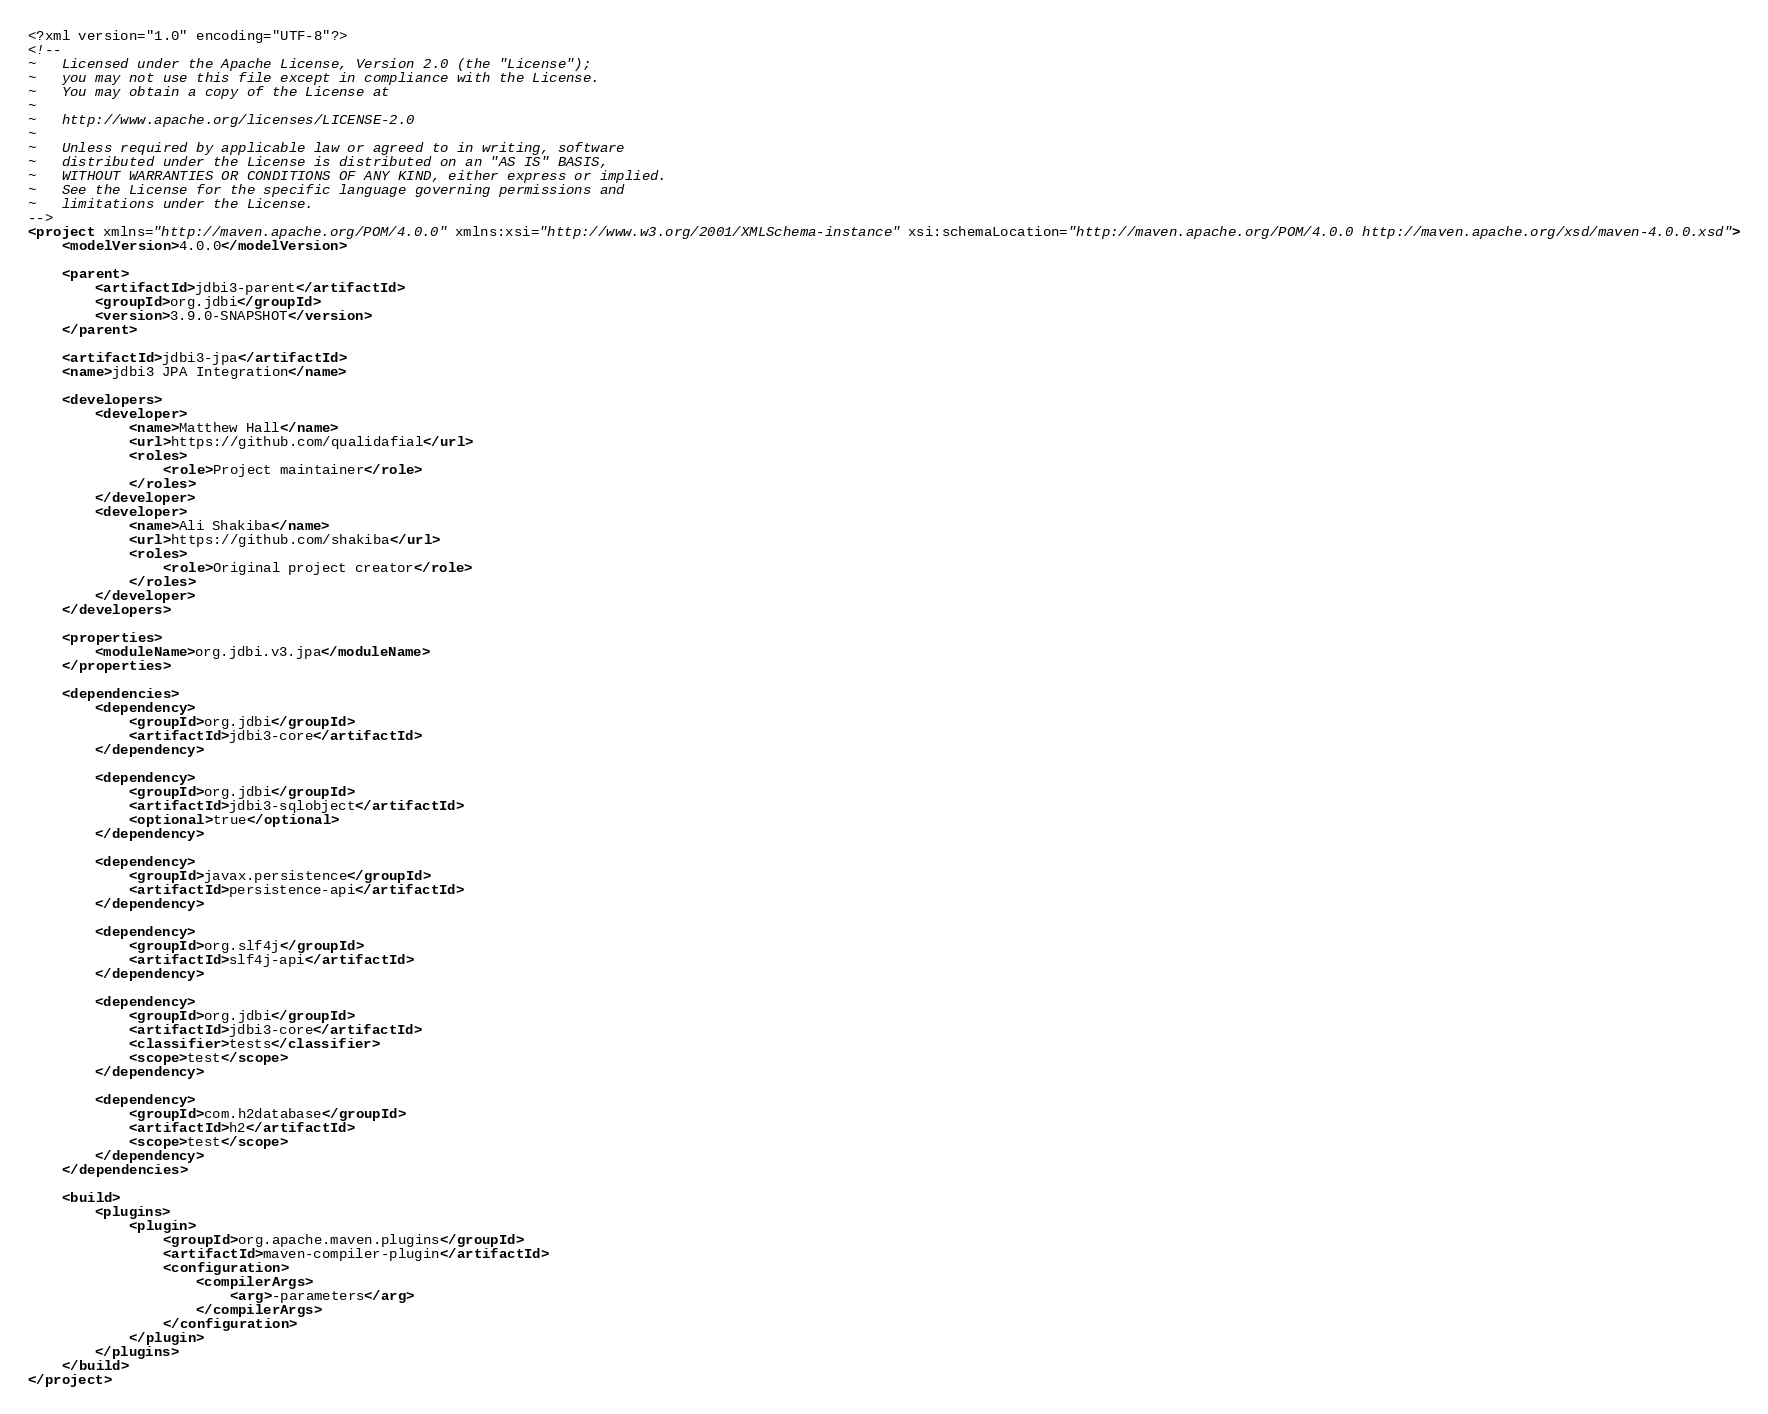Convert code to text. <code><loc_0><loc_0><loc_500><loc_500><_XML_><?xml version="1.0" encoding="UTF-8"?>
<!--
~   Licensed under the Apache License, Version 2.0 (the "License");
~   you may not use this file except in compliance with the License.
~   You may obtain a copy of the License at
~
~   http://www.apache.org/licenses/LICENSE-2.0
~
~   Unless required by applicable law or agreed to in writing, software
~   distributed under the License is distributed on an "AS IS" BASIS,
~   WITHOUT WARRANTIES OR CONDITIONS OF ANY KIND, either express or implied.
~   See the License for the specific language governing permissions and
~   limitations under the License.
-->
<project xmlns="http://maven.apache.org/POM/4.0.0" xmlns:xsi="http://www.w3.org/2001/XMLSchema-instance" xsi:schemaLocation="http://maven.apache.org/POM/4.0.0 http://maven.apache.org/xsd/maven-4.0.0.xsd">
    <modelVersion>4.0.0</modelVersion>

    <parent>
        <artifactId>jdbi3-parent</artifactId>
        <groupId>org.jdbi</groupId>
        <version>3.9.0-SNAPSHOT</version>
    </parent>

    <artifactId>jdbi3-jpa</artifactId>
    <name>jdbi3 JPA Integration</name>

    <developers>
        <developer>
            <name>Matthew Hall</name>
            <url>https://github.com/qualidafial</url>
            <roles>
                <role>Project maintainer</role>
            </roles>
        </developer>
        <developer>
            <name>Ali Shakiba</name>
            <url>https://github.com/shakiba</url>
            <roles>
                <role>Original project creator</role>
            </roles>
        </developer>
    </developers>

    <properties>
        <moduleName>org.jdbi.v3.jpa</moduleName>
    </properties>

    <dependencies>
        <dependency>
            <groupId>org.jdbi</groupId>
            <artifactId>jdbi3-core</artifactId>
        </dependency>

        <dependency>
            <groupId>org.jdbi</groupId>
            <artifactId>jdbi3-sqlobject</artifactId>
            <optional>true</optional>
        </dependency>

        <dependency>
            <groupId>javax.persistence</groupId>
            <artifactId>persistence-api</artifactId>
        </dependency>

        <dependency>
            <groupId>org.slf4j</groupId>
            <artifactId>slf4j-api</artifactId>
        </dependency>

        <dependency>
            <groupId>org.jdbi</groupId>
            <artifactId>jdbi3-core</artifactId>
            <classifier>tests</classifier>
            <scope>test</scope>
        </dependency>

        <dependency>
            <groupId>com.h2database</groupId>
            <artifactId>h2</artifactId>
            <scope>test</scope>
        </dependency>
    </dependencies>

    <build>
        <plugins>
            <plugin>
                <groupId>org.apache.maven.plugins</groupId>
                <artifactId>maven-compiler-plugin</artifactId>
                <configuration>
                    <compilerArgs>
                        <arg>-parameters</arg>
                    </compilerArgs>
                </configuration>
            </plugin>
        </plugins>
    </build>
</project>
</code> 